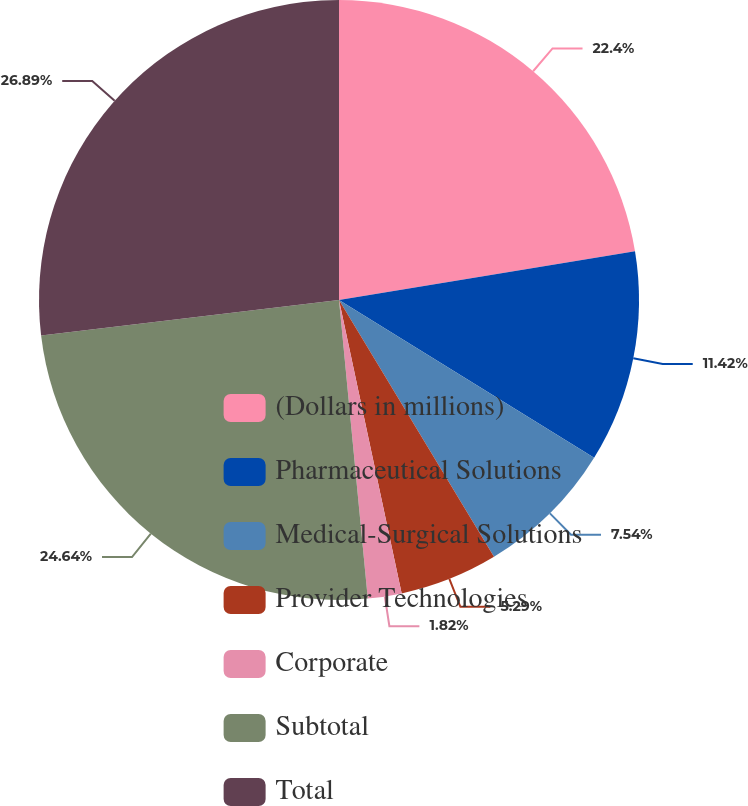<chart> <loc_0><loc_0><loc_500><loc_500><pie_chart><fcel>(Dollars in millions)<fcel>Pharmaceutical Solutions<fcel>Medical-Surgical Solutions<fcel>Provider Technologies<fcel>Corporate<fcel>Subtotal<fcel>Total<nl><fcel>22.4%<fcel>11.42%<fcel>7.54%<fcel>5.29%<fcel>1.82%<fcel>24.64%<fcel>26.89%<nl></chart> 